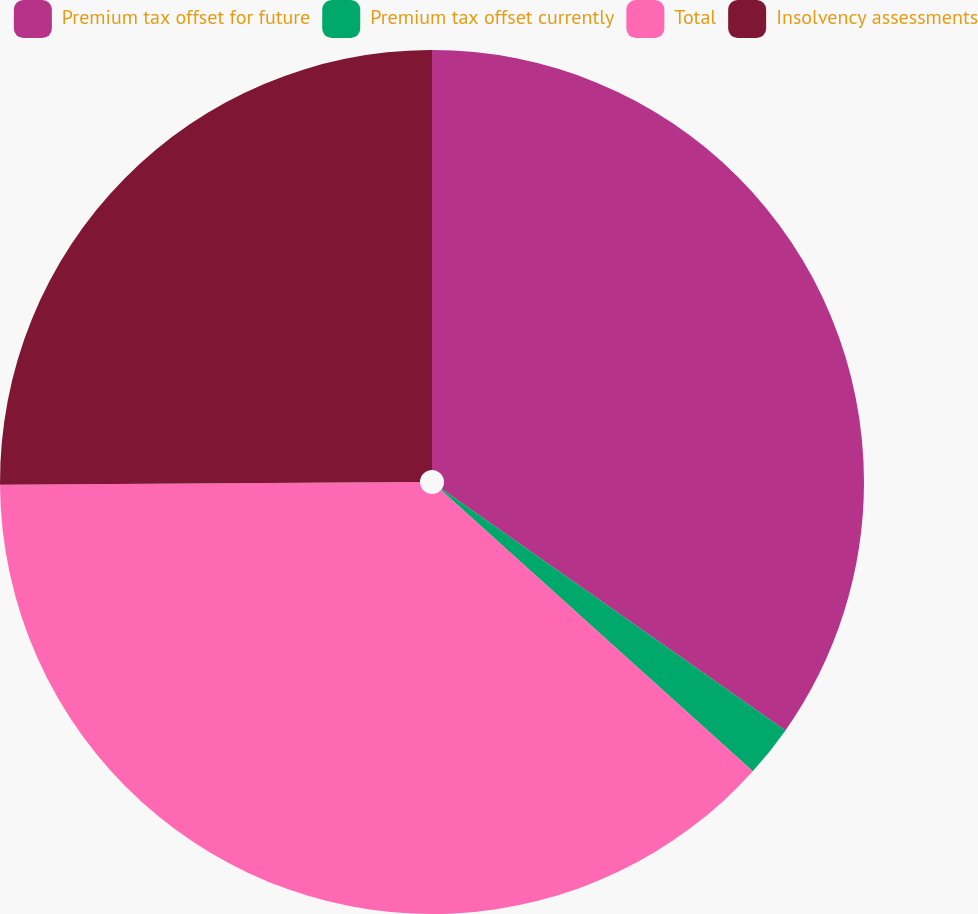Convert chart. <chart><loc_0><loc_0><loc_500><loc_500><pie_chart><fcel>Premium tax offset for future<fcel>Premium tax offset currently<fcel>Total<fcel>Insolvency assessments<nl><fcel>34.75%<fcel>1.93%<fcel>38.22%<fcel>25.1%<nl></chart> 